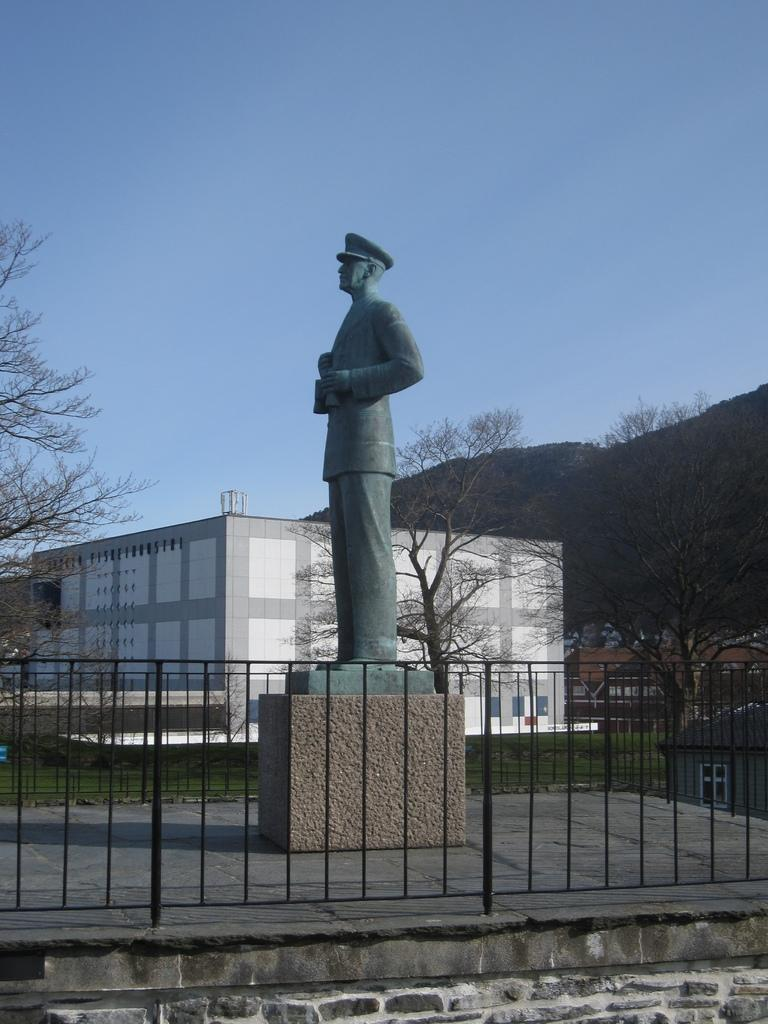What type of structure can be seen in the image? There is a fencing in the image. What is located behind the fencing? There is a statue behind the fencing. What is the setting of the statue? There are trees on either side of the statue. What can be seen in the background of the image? There is a building, a mountain, and the sky visible in the background of the image. What type of reaction does the hat have to the statue in the image? There is no hat present in the image, so it cannot have a reaction to the statue. 